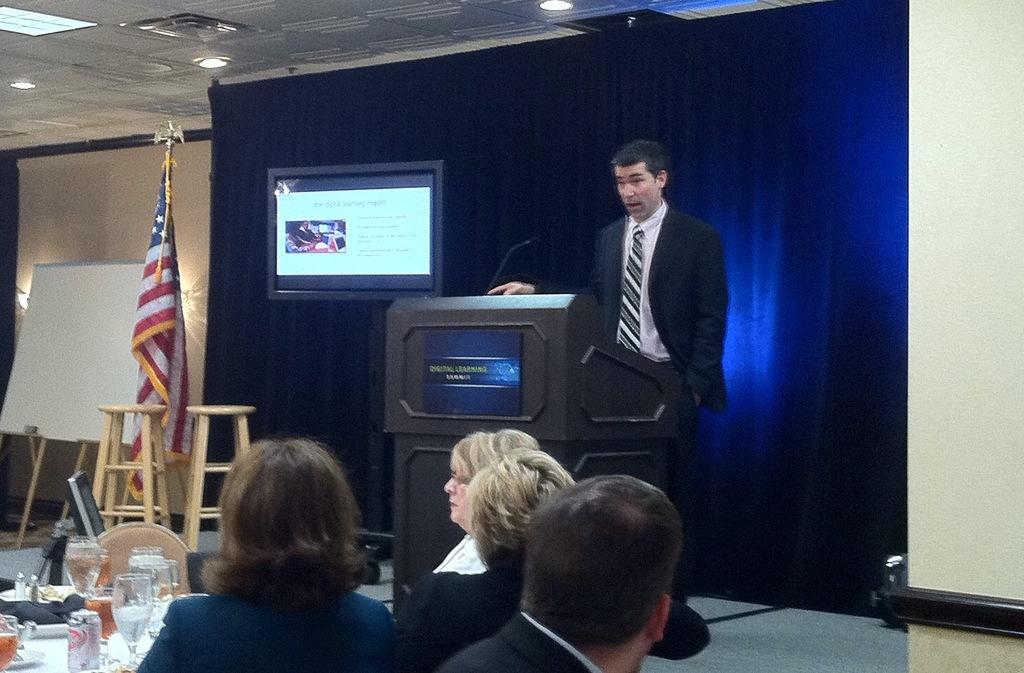Can you describe this image briefly? In this image w can see a few people sitting and a person is standing on the stage near a podium and a mic to the podium, in the left side there is a screen, stools, flag, white board, a table, on the table there are glasses, a tin and few objects and lights to the ceiling. 